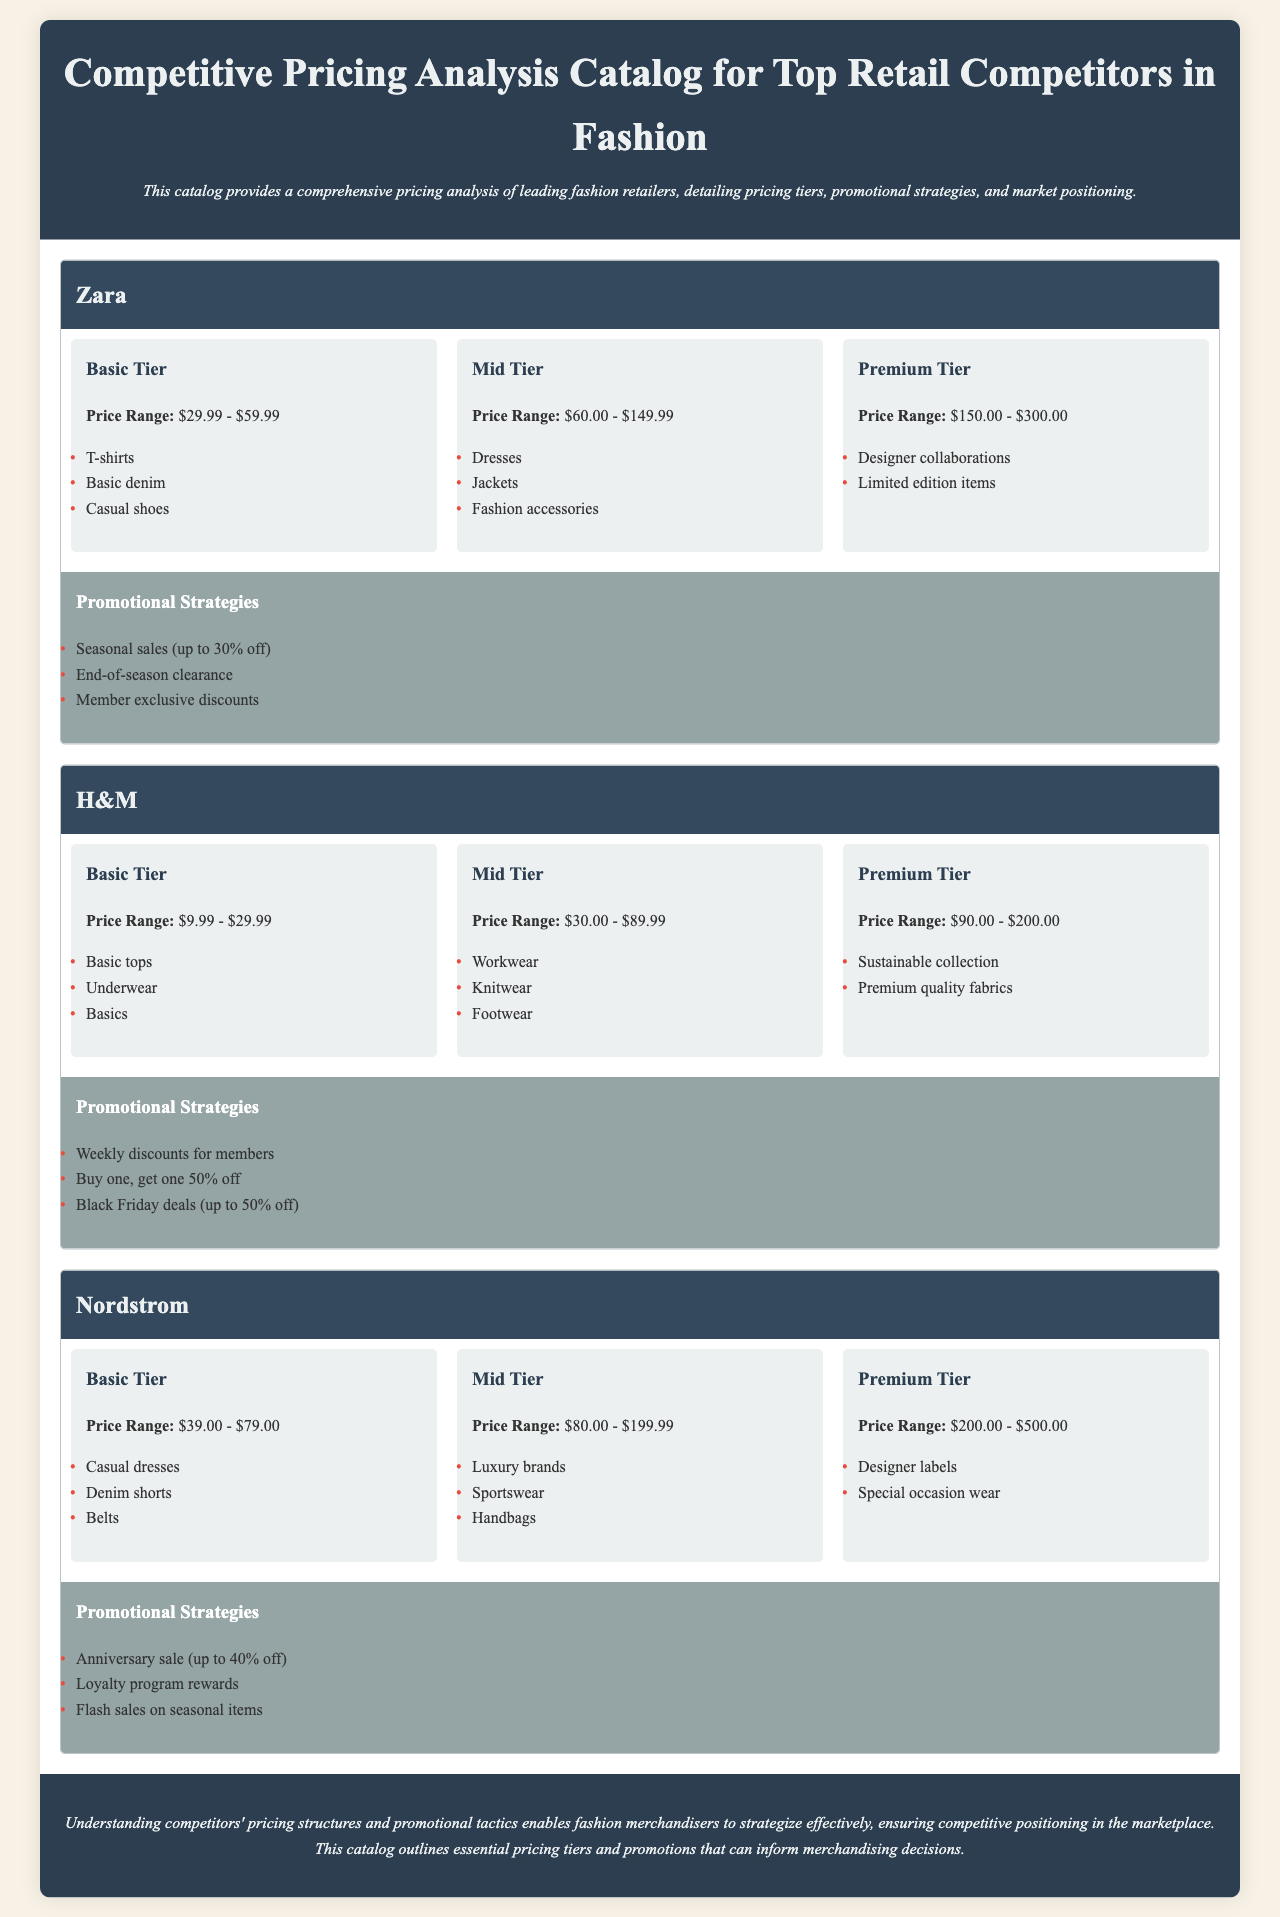What is the price range for Zara's Basic Tier? The price range for Zara's Basic Tier is included in the pricing section of the document, which states it is $29.99 - $59.99.
Answer: $29.99 - $59.99 What type of items are included in H&M's Premium Tier? H&M's Premium Tier details are found under its pricing tiers and list the items as Sustainable collection and Premium quality fabrics.
Answer: Sustainable collection, Premium quality fabrics How much can customers save during Nordstrom's Anniversary sale? The promotional strategies for Nordstrom indicate that customers can save up to 40% during the Anniversary sale.
Answer: 40% off What is the price range for Zara's Premium Tier? The specific pricing tiers for Zara are mentioned in the document, with the Premium Tier price range being $150.00 - $300.00.
Answer: $150.00 - $300.00 What is one of H&M's promotional strategies? H&M's promotional strategies include a variety of tactics, one being Buy one, get one 50% off, as described in the document.
Answer: Buy one, get one 50% off What items fall under Nordstrom's Mid Tier? The document lists items under Nordstrom's Mid Tier as Luxury brands, Sportswear, and Handbags.
Answer: Luxury brands, Sportswear, Handbags What are the three pricing tiers at Zara? The document specifies that Zara's pricing tiers are Basic Tier, Mid Tier, and Premium Tier.
Answer: Basic Tier, Mid Tier, Premium Tier How often does H&M provide weekly discounts? The promotional strategies section of H&M states that they offer weekly discounts for members.
Answer: Weekly What does the conclusion emphasize regarding pricing structures? The conclusion summarizes the importance of understanding pricing structures, but particularly emphasizes ensuring competitive positioning in the marketplace.
Answer: Competitive positioning 